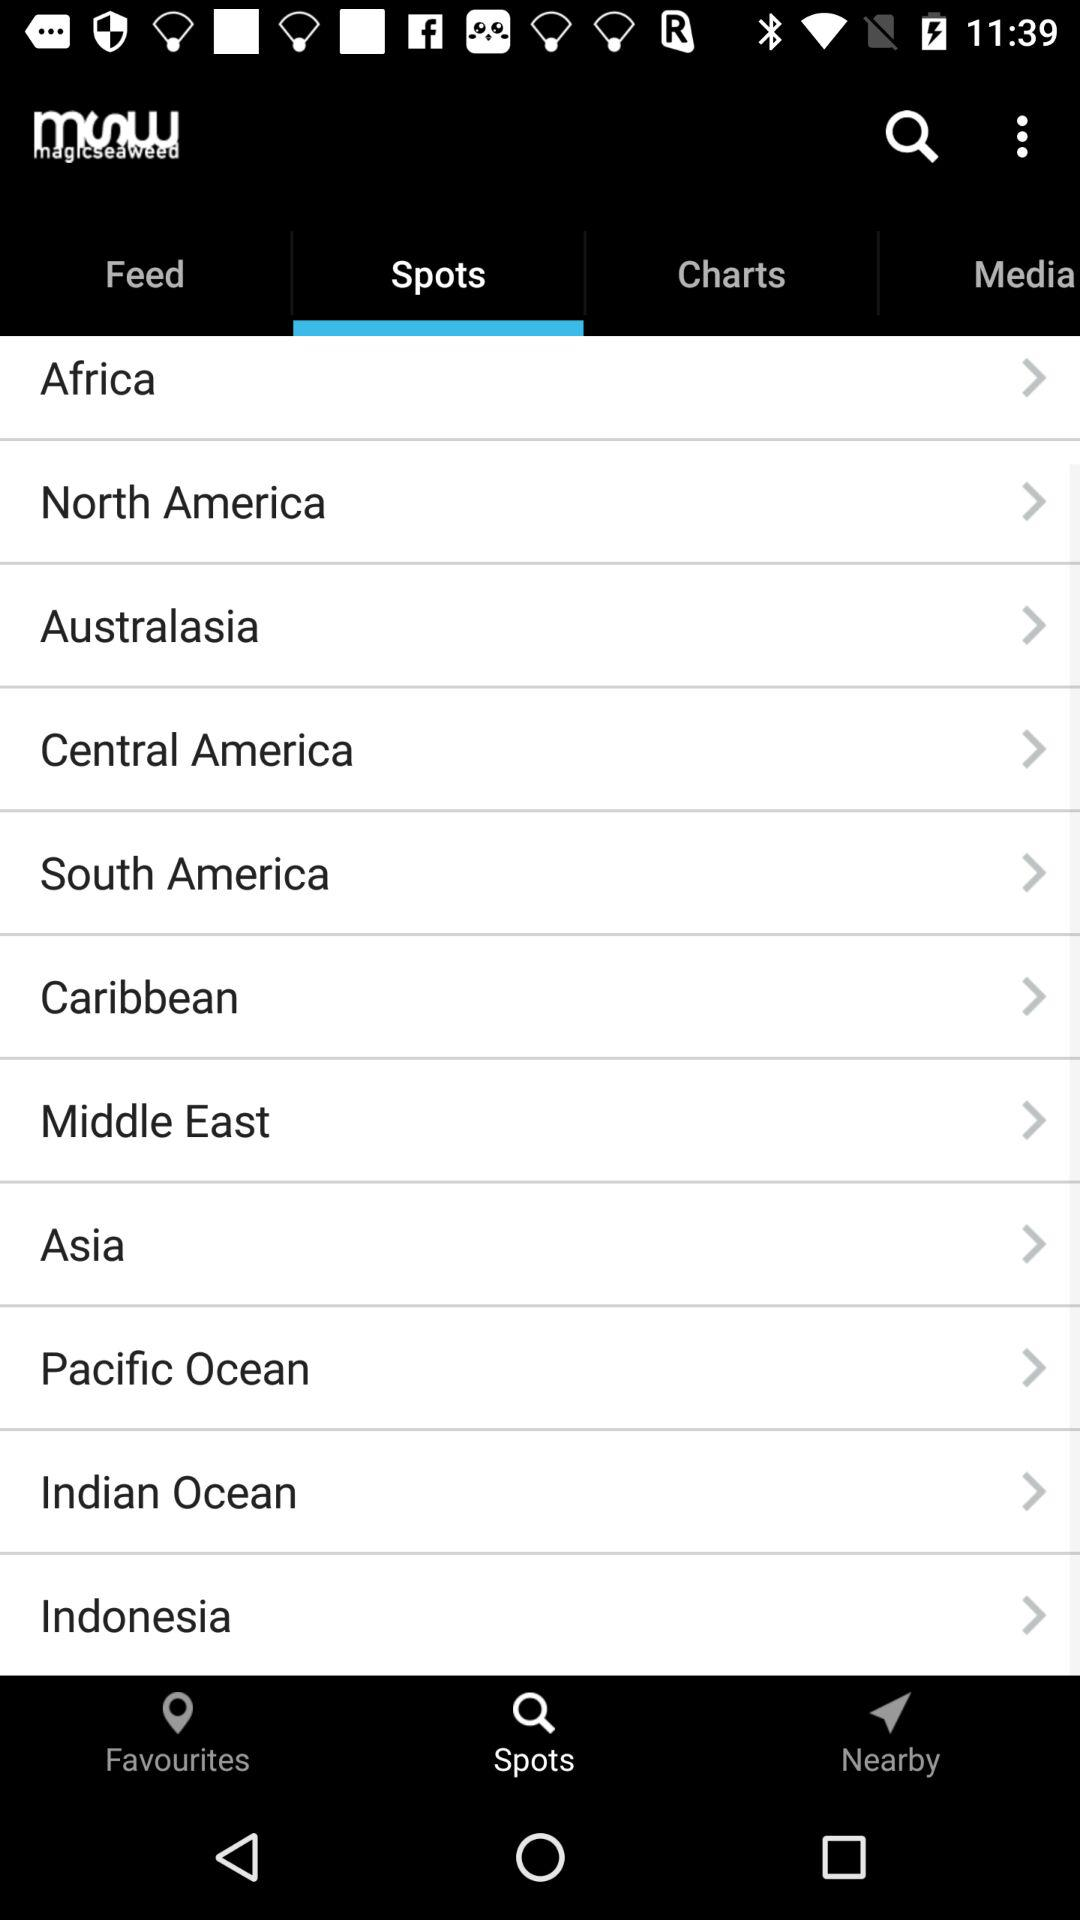What is the name of the application? The name of the application is "msw magicseaweed". 